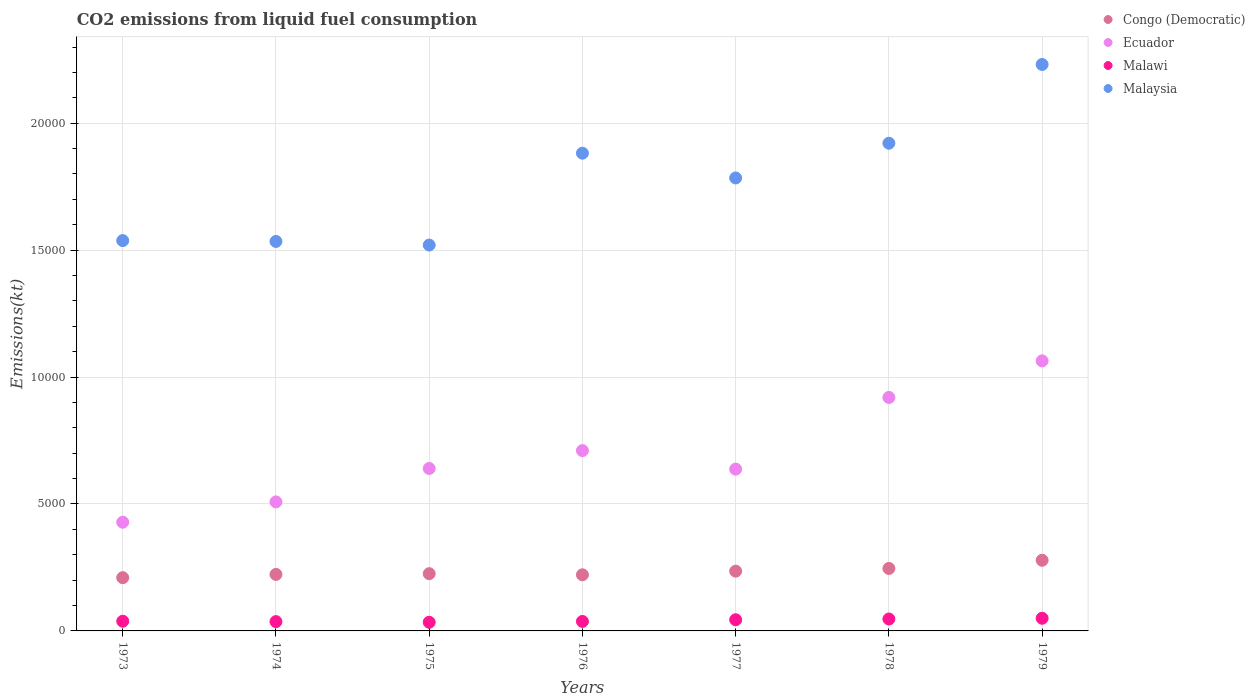How many different coloured dotlines are there?
Your answer should be compact. 4. Is the number of dotlines equal to the number of legend labels?
Make the answer very short. Yes. What is the amount of CO2 emitted in Ecuador in 1974?
Keep it short and to the point. 5082.46. Across all years, what is the maximum amount of CO2 emitted in Malawi?
Your answer should be compact. 498.71. Across all years, what is the minimum amount of CO2 emitted in Malawi?
Your response must be concise. 341.03. In which year was the amount of CO2 emitted in Malaysia maximum?
Offer a very short reply. 1979. What is the total amount of CO2 emitted in Malaysia in the graph?
Give a very brief answer. 1.24e+05. What is the difference between the amount of CO2 emitted in Congo (Democratic) in 1974 and that in 1975?
Offer a terse response. -29.34. What is the difference between the amount of CO2 emitted in Malawi in 1979 and the amount of CO2 emitted in Malaysia in 1978?
Provide a short and direct response. -1.87e+04. What is the average amount of CO2 emitted in Malaysia per year?
Your answer should be compact. 1.77e+04. In the year 1977, what is the difference between the amount of CO2 emitted in Malaysia and amount of CO2 emitted in Ecuador?
Offer a very short reply. 1.15e+04. In how many years, is the amount of CO2 emitted in Congo (Democratic) greater than 13000 kt?
Make the answer very short. 0. What is the ratio of the amount of CO2 emitted in Malaysia in 1977 to that in 1978?
Provide a succinct answer. 0.93. Is the amount of CO2 emitted in Congo (Democratic) in 1976 less than that in 1978?
Your answer should be very brief. Yes. What is the difference between the highest and the second highest amount of CO2 emitted in Malaysia?
Your response must be concise. 3102.28. What is the difference between the highest and the lowest amount of CO2 emitted in Congo (Democratic)?
Provide a succinct answer. 685.73. Is the sum of the amount of CO2 emitted in Malaysia in 1975 and 1977 greater than the maximum amount of CO2 emitted in Ecuador across all years?
Your response must be concise. Yes. Is it the case that in every year, the sum of the amount of CO2 emitted in Congo (Democratic) and amount of CO2 emitted in Ecuador  is greater than the amount of CO2 emitted in Malaysia?
Ensure brevity in your answer.  No. Does the amount of CO2 emitted in Ecuador monotonically increase over the years?
Provide a succinct answer. No. How many dotlines are there?
Offer a very short reply. 4. What is the difference between two consecutive major ticks on the Y-axis?
Offer a terse response. 5000. Does the graph contain any zero values?
Provide a short and direct response. No. Does the graph contain grids?
Provide a short and direct response. Yes. How many legend labels are there?
Provide a short and direct response. 4. What is the title of the graph?
Offer a terse response. CO2 emissions from liquid fuel consumption. Does "Lebanon" appear as one of the legend labels in the graph?
Offer a terse response. No. What is the label or title of the Y-axis?
Your answer should be compact. Emissions(kt). What is the Emissions(kt) of Congo (Democratic) in 1973?
Keep it short and to the point. 2097.52. What is the Emissions(kt) in Ecuador in 1973?
Your answer should be very brief. 4283.06. What is the Emissions(kt) in Malawi in 1973?
Keep it short and to the point. 381.37. What is the Emissions(kt) of Malaysia in 1973?
Your answer should be very brief. 1.54e+04. What is the Emissions(kt) in Congo (Democratic) in 1974?
Make the answer very short. 2225.87. What is the Emissions(kt) of Ecuador in 1974?
Give a very brief answer. 5082.46. What is the Emissions(kt) in Malawi in 1974?
Your response must be concise. 366.7. What is the Emissions(kt) in Malaysia in 1974?
Offer a very short reply. 1.53e+04. What is the Emissions(kt) in Congo (Democratic) in 1975?
Offer a terse response. 2255.2. What is the Emissions(kt) of Ecuador in 1975?
Provide a short and direct response. 6398.91. What is the Emissions(kt) in Malawi in 1975?
Offer a terse response. 341.03. What is the Emissions(kt) in Malaysia in 1975?
Keep it short and to the point. 1.52e+04. What is the Emissions(kt) of Congo (Democratic) in 1976?
Provide a short and direct response. 2211.2. What is the Emissions(kt) in Ecuador in 1976?
Offer a terse response. 7102.98. What is the Emissions(kt) in Malawi in 1976?
Make the answer very short. 374.03. What is the Emissions(kt) in Malaysia in 1976?
Keep it short and to the point. 1.88e+04. What is the Emissions(kt) of Congo (Democratic) in 1977?
Provide a succinct answer. 2354.21. What is the Emissions(kt) in Ecuador in 1977?
Offer a terse response. 6373.25. What is the Emissions(kt) in Malawi in 1977?
Your answer should be compact. 440.04. What is the Emissions(kt) in Malaysia in 1977?
Ensure brevity in your answer.  1.78e+04. What is the Emissions(kt) of Congo (Democratic) in 1978?
Ensure brevity in your answer.  2460.56. What is the Emissions(kt) of Ecuador in 1978?
Provide a succinct answer. 9196.84. What is the Emissions(kt) of Malawi in 1978?
Provide a short and direct response. 469.38. What is the Emissions(kt) of Malaysia in 1978?
Ensure brevity in your answer.  1.92e+04. What is the Emissions(kt) in Congo (Democratic) in 1979?
Provide a short and direct response. 2783.25. What is the Emissions(kt) of Ecuador in 1979?
Make the answer very short. 1.06e+04. What is the Emissions(kt) in Malawi in 1979?
Your answer should be very brief. 498.71. What is the Emissions(kt) in Malaysia in 1979?
Provide a short and direct response. 2.23e+04. Across all years, what is the maximum Emissions(kt) of Congo (Democratic)?
Provide a short and direct response. 2783.25. Across all years, what is the maximum Emissions(kt) in Ecuador?
Your answer should be compact. 1.06e+04. Across all years, what is the maximum Emissions(kt) of Malawi?
Ensure brevity in your answer.  498.71. Across all years, what is the maximum Emissions(kt) in Malaysia?
Provide a succinct answer. 2.23e+04. Across all years, what is the minimum Emissions(kt) in Congo (Democratic)?
Provide a short and direct response. 2097.52. Across all years, what is the minimum Emissions(kt) in Ecuador?
Keep it short and to the point. 4283.06. Across all years, what is the minimum Emissions(kt) of Malawi?
Your answer should be very brief. 341.03. Across all years, what is the minimum Emissions(kt) in Malaysia?
Offer a terse response. 1.52e+04. What is the total Emissions(kt) of Congo (Democratic) in the graph?
Give a very brief answer. 1.64e+04. What is the total Emissions(kt) in Ecuador in the graph?
Your answer should be very brief. 4.91e+04. What is the total Emissions(kt) in Malawi in the graph?
Your answer should be compact. 2871.26. What is the total Emissions(kt) in Malaysia in the graph?
Your answer should be very brief. 1.24e+05. What is the difference between the Emissions(kt) of Congo (Democratic) in 1973 and that in 1974?
Keep it short and to the point. -128.34. What is the difference between the Emissions(kt) of Ecuador in 1973 and that in 1974?
Provide a short and direct response. -799.41. What is the difference between the Emissions(kt) in Malawi in 1973 and that in 1974?
Ensure brevity in your answer.  14.67. What is the difference between the Emissions(kt) in Malaysia in 1973 and that in 1974?
Your response must be concise. 33. What is the difference between the Emissions(kt) of Congo (Democratic) in 1973 and that in 1975?
Make the answer very short. -157.68. What is the difference between the Emissions(kt) of Ecuador in 1973 and that in 1975?
Provide a succinct answer. -2115.86. What is the difference between the Emissions(kt) in Malawi in 1973 and that in 1975?
Ensure brevity in your answer.  40.34. What is the difference between the Emissions(kt) of Malaysia in 1973 and that in 1975?
Provide a short and direct response. 176.02. What is the difference between the Emissions(kt) of Congo (Democratic) in 1973 and that in 1976?
Provide a succinct answer. -113.68. What is the difference between the Emissions(kt) in Ecuador in 1973 and that in 1976?
Your answer should be very brief. -2819.92. What is the difference between the Emissions(kt) in Malawi in 1973 and that in 1976?
Offer a terse response. 7.33. What is the difference between the Emissions(kt) in Malaysia in 1973 and that in 1976?
Your answer should be very brief. -3443.31. What is the difference between the Emissions(kt) of Congo (Democratic) in 1973 and that in 1977?
Your response must be concise. -256.69. What is the difference between the Emissions(kt) in Ecuador in 1973 and that in 1977?
Give a very brief answer. -2090.19. What is the difference between the Emissions(kt) in Malawi in 1973 and that in 1977?
Ensure brevity in your answer.  -58.67. What is the difference between the Emissions(kt) in Malaysia in 1973 and that in 1977?
Ensure brevity in your answer.  -2467.89. What is the difference between the Emissions(kt) in Congo (Democratic) in 1973 and that in 1978?
Your answer should be compact. -363.03. What is the difference between the Emissions(kt) of Ecuador in 1973 and that in 1978?
Provide a short and direct response. -4913.78. What is the difference between the Emissions(kt) in Malawi in 1973 and that in 1978?
Give a very brief answer. -88.01. What is the difference between the Emissions(kt) of Malaysia in 1973 and that in 1978?
Your answer should be very brief. -3835.68. What is the difference between the Emissions(kt) in Congo (Democratic) in 1973 and that in 1979?
Provide a succinct answer. -685.73. What is the difference between the Emissions(kt) in Ecuador in 1973 and that in 1979?
Offer a very short reply. -6354.91. What is the difference between the Emissions(kt) of Malawi in 1973 and that in 1979?
Make the answer very short. -117.34. What is the difference between the Emissions(kt) in Malaysia in 1973 and that in 1979?
Provide a succinct answer. -6937.96. What is the difference between the Emissions(kt) of Congo (Democratic) in 1974 and that in 1975?
Provide a succinct answer. -29.34. What is the difference between the Emissions(kt) in Ecuador in 1974 and that in 1975?
Give a very brief answer. -1316.45. What is the difference between the Emissions(kt) of Malawi in 1974 and that in 1975?
Keep it short and to the point. 25.67. What is the difference between the Emissions(kt) in Malaysia in 1974 and that in 1975?
Make the answer very short. 143.01. What is the difference between the Emissions(kt) of Congo (Democratic) in 1974 and that in 1976?
Give a very brief answer. 14.67. What is the difference between the Emissions(kt) of Ecuador in 1974 and that in 1976?
Make the answer very short. -2020.52. What is the difference between the Emissions(kt) of Malawi in 1974 and that in 1976?
Offer a very short reply. -7.33. What is the difference between the Emissions(kt) of Malaysia in 1974 and that in 1976?
Your answer should be compact. -3476.32. What is the difference between the Emissions(kt) of Congo (Democratic) in 1974 and that in 1977?
Ensure brevity in your answer.  -128.34. What is the difference between the Emissions(kt) of Ecuador in 1974 and that in 1977?
Offer a terse response. -1290.78. What is the difference between the Emissions(kt) of Malawi in 1974 and that in 1977?
Provide a short and direct response. -73.34. What is the difference between the Emissions(kt) of Malaysia in 1974 and that in 1977?
Offer a terse response. -2500.89. What is the difference between the Emissions(kt) of Congo (Democratic) in 1974 and that in 1978?
Provide a succinct answer. -234.69. What is the difference between the Emissions(kt) of Ecuador in 1974 and that in 1978?
Your response must be concise. -4114.37. What is the difference between the Emissions(kt) in Malawi in 1974 and that in 1978?
Provide a short and direct response. -102.68. What is the difference between the Emissions(kt) of Malaysia in 1974 and that in 1978?
Provide a succinct answer. -3868.68. What is the difference between the Emissions(kt) in Congo (Democratic) in 1974 and that in 1979?
Give a very brief answer. -557.38. What is the difference between the Emissions(kt) of Ecuador in 1974 and that in 1979?
Make the answer very short. -5555.51. What is the difference between the Emissions(kt) in Malawi in 1974 and that in 1979?
Offer a very short reply. -132.01. What is the difference between the Emissions(kt) of Malaysia in 1974 and that in 1979?
Keep it short and to the point. -6970.97. What is the difference between the Emissions(kt) in Congo (Democratic) in 1975 and that in 1976?
Your answer should be compact. 44. What is the difference between the Emissions(kt) in Ecuador in 1975 and that in 1976?
Give a very brief answer. -704.06. What is the difference between the Emissions(kt) of Malawi in 1975 and that in 1976?
Make the answer very short. -33. What is the difference between the Emissions(kt) in Malaysia in 1975 and that in 1976?
Keep it short and to the point. -3619.33. What is the difference between the Emissions(kt) in Congo (Democratic) in 1975 and that in 1977?
Ensure brevity in your answer.  -99.01. What is the difference between the Emissions(kt) of Ecuador in 1975 and that in 1977?
Your response must be concise. 25.67. What is the difference between the Emissions(kt) of Malawi in 1975 and that in 1977?
Provide a short and direct response. -99.01. What is the difference between the Emissions(kt) in Malaysia in 1975 and that in 1977?
Your answer should be very brief. -2643.91. What is the difference between the Emissions(kt) in Congo (Democratic) in 1975 and that in 1978?
Provide a succinct answer. -205.35. What is the difference between the Emissions(kt) of Ecuador in 1975 and that in 1978?
Give a very brief answer. -2797.92. What is the difference between the Emissions(kt) in Malawi in 1975 and that in 1978?
Make the answer very short. -128.34. What is the difference between the Emissions(kt) in Malaysia in 1975 and that in 1978?
Offer a very short reply. -4011.7. What is the difference between the Emissions(kt) in Congo (Democratic) in 1975 and that in 1979?
Your answer should be very brief. -528.05. What is the difference between the Emissions(kt) in Ecuador in 1975 and that in 1979?
Give a very brief answer. -4239.05. What is the difference between the Emissions(kt) in Malawi in 1975 and that in 1979?
Your response must be concise. -157.68. What is the difference between the Emissions(kt) of Malaysia in 1975 and that in 1979?
Ensure brevity in your answer.  -7113.98. What is the difference between the Emissions(kt) in Congo (Democratic) in 1976 and that in 1977?
Offer a terse response. -143.01. What is the difference between the Emissions(kt) of Ecuador in 1976 and that in 1977?
Your response must be concise. 729.73. What is the difference between the Emissions(kt) in Malawi in 1976 and that in 1977?
Keep it short and to the point. -66.01. What is the difference between the Emissions(kt) of Malaysia in 1976 and that in 1977?
Your answer should be compact. 975.42. What is the difference between the Emissions(kt) of Congo (Democratic) in 1976 and that in 1978?
Your response must be concise. -249.36. What is the difference between the Emissions(kt) of Ecuador in 1976 and that in 1978?
Provide a succinct answer. -2093.86. What is the difference between the Emissions(kt) of Malawi in 1976 and that in 1978?
Provide a short and direct response. -95.34. What is the difference between the Emissions(kt) of Malaysia in 1976 and that in 1978?
Your answer should be very brief. -392.37. What is the difference between the Emissions(kt) of Congo (Democratic) in 1976 and that in 1979?
Make the answer very short. -572.05. What is the difference between the Emissions(kt) of Ecuador in 1976 and that in 1979?
Offer a very short reply. -3534.99. What is the difference between the Emissions(kt) of Malawi in 1976 and that in 1979?
Provide a succinct answer. -124.68. What is the difference between the Emissions(kt) in Malaysia in 1976 and that in 1979?
Ensure brevity in your answer.  -3494.65. What is the difference between the Emissions(kt) of Congo (Democratic) in 1977 and that in 1978?
Offer a terse response. -106.34. What is the difference between the Emissions(kt) in Ecuador in 1977 and that in 1978?
Ensure brevity in your answer.  -2823.59. What is the difference between the Emissions(kt) of Malawi in 1977 and that in 1978?
Offer a terse response. -29.34. What is the difference between the Emissions(kt) in Malaysia in 1977 and that in 1978?
Offer a very short reply. -1367.79. What is the difference between the Emissions(kt) of Congo (Democratic) in 1977 and that in 1979?
Offer a very short reply. -429.04. What is the difference between the Emissions(kt) of Ecuador in 1977 and that in 1979?
Ensure brevity in your answer.  -4264.72. What is the difference between the Emissions(kt) in Malawi in 1977 and that in 1979?
Your answer should be compact. -58.67. What is the difference between the Emissions(kt) in Malaysia in 1977 and that in 1979?
Ensure brevity in your answer.  -4470.07. What is the difference between the Emissions(kt) of Congo (Democratic) in 1978 and that in 1979?
Give a very brief answer. -322.7. What is the difference between the Emissions(kt) in Ecuador in 1978 and that in 1979?
Make the answer very short. -1441.13. What is the difference between the Emissions(kt) in Malawi in 1978 and that in 1979?
Make the answer very short. -29.34. What is the difference between the Emissions(kt) of Malaysia in 1978 and that in 1979?
Your response must be concise. -3102.28. What is the difference between the Emissions(kt) of Congo (Democratic) in 1973 and the Emissions(kt) of Ecuador in 1974?
Provide a short and direct response. -2984.94. What is the difference between the Emissions(kt) in Congo (Democratic) in 1973 and the Emissions(kt) in Malawi in 1974?
Offer a very short reply. 1730.82. What is the difference between the Emissions(kt) of Congo (Democratic) in 1973 and the Emissions(kt) of Malaysia in 1974?
Give a very brief answer. -1.32e+04. What is the difference between the Emissions(kt) in Ecuador in 1973 and the Emissions(kt) in Malawi in 1974?
Provide a succinct answer. 3916.36. What is the difference between the Emissions(kt) in Ecuador in 1973 and the Emissions(kt) in Malaysia in 1974?
Ensure brevity in your answer.  -1.11e+04. What is the difference between the Emissions(kt) of Malawi in 1973 and the Emissions(kt) of Malaysia in 1974?
Keep it short and to the point. -1.50e+04. What is the difference between the Emissions(kt) of Congo (Democratic) in 1973 and the Emissions(kt) of Ecuador in 1975?
Ensure brevity in your answer.  -4301.39. What is the difference between the Emissions(kt) of Congo (Democratic) in 1973 and the Emissions(kt) of Malawi in 1975?
Give a very brief answer. 1756.49. What is the difference between the Emissions(kt) in Congo (Democratic) in 1973 and the Emissions(kt) in Malaysia in 1975?
Your answer should be compact. -1.31e+04. What is the difference between the Emissions(kt) in Ecuador in 1973 and the Emissions(kt) in Malawi in 1975?
Offer a terse response. 3942.03. What is the difference between the Emissions(kt) in Ecuador in 1973 and the Emissions(kt) in Malaysia in 1975?
Make the answer very short. -1.09e+04. What is the difference between the Emissions(kt) of Malawi in 1973 and the Emissions(kt) of Malaysia in 1975?
Keep it short and to the point. -1.48e+04. What is the difference between the Emissions(kt) in Congo (Democratic) in 1973 and the Emissions(kt) in Ecuador in 1976?
Provide a succinct answer. -5005.45. What is the difference between the Emissions(kt) in Congo (Democratic) in 1973 and the Emissions(kt) in Malawi in 1976?
Ensure brevity in your answer.  1723.49. What is the difference between the Emissions(kt) of Congo (Democratic) in 1973 and the Emissions(kt) of Malaysia in 1976?
Keep it short and to the point. -1.67e+04. What is the difference between the Emissions(kt) of Ecuador in 1973 and the Emissions(kt) of Malawi in 1976?
Your answer should be very brief. 3909.02. What is the difference between the Emissions(kt) of Ecuador in 1973 and the Emissions(kt) of Malaysia in 1976?
Ensure brevity in your answer.  -1.45e+04. What is the difference between the Emissions(kt) of Malawi in 1973 and the Emissions(kt) of Malaysia in 1976?
Your response must be concise. -1.84e+04. What is the difference between the Emissions(kt) of Congo (Democratic) in 1973 and the Emissions(kt) of Ecuador in 1977?
Provide a short and direct response. -4275.72. What is the difference between the Emissions(kt) in Congo (Democratic) in 1973 and the Emissions(kt) in Malawi in 1977?
Your response must be concise. 1657.48. What is the difference between the Emissions(kt) in Congo (Democratic) in 1973 and the Emissions(kt) in Malaysia in 1977?
Provide a short and direct response. -1.57e+04. What is the difference between the Emissions(kt) in Ecuador in 1973 and the Emissions(kt) in Malawi in 1977?
Your answer should be very brief. 3843.02. What is the difference between the Emissions(kt) of Ecuador in 1973 and the Emissions(kt) of Malaysia in 1977?
Provide a succinct answer. -1.36e+04. What is the difference between the Emissions(kt) in Malawi in 1973 and the Emissions(kt) in Malaysia in 1977?
Your answer should be very brief. -1.75e+04. What is the difference between the Emissions(kt) of Congo (Democratic) in 1973 and the Emissions(kt) of Ecuador in 1978?
Offer a terse response. -7099.31. What is the difference between the Emissions(kt) in Congo (Democratic) in 1973 and the Emissions(kt) in Malawi in 1978?
Provide a short and direct response. 1628.15. What is the difference between the Emissions(kt) in Congo (Democratic) in 1973 and the Emissions(kt) in Malaysia in 1978?
Your response must be concise. -1.71e+04. What is the difference between the Emissions(kt) in Ecuador in 1973 and the Emissions(kt) in Malawi in 1978?
Provide a short and direct response. 3813.68. What is the difference between the Emissions(kt) of Ecuador in 1973 and the Emissions(kt) of Malaysia in 1978?
Offer a very short reply. -1.49e+04. What is the difference between the Emissions(kt) of Malawi in 1973 and the Emissions(kt) of Malaysia in 1978?
Keep it short and to the point. -1.88e+04. What is the difference between the Emissions(kt) of Congo (Democratic) in 1973 and the Emissions(kt) of Ecuador in 1979?
Keep it short and to the point. -8540.44. What is the difference between the Emissions(kt) of Congo (Democratic) in 1973 and the Emissions(kt) of Malawi in 1979?
Your response must be concise. 1598.81. What is the difference between the Emissions(kt) of Congo (Democratic) in 1973 and the Emissions(kt) of Malaysia in 1979?
Provide a succinct answer. -2.02e+04. What is the difference between the Emissions(kt) of Ecuador in 1973 and the Emissions(kt) of Malawi in 1979?
Your answer should be very brief. 3784.34. What is the difference between the Emissions(kt) in Ecuador in 1973 and the Emissions(kt) in Malaysia in 1979?
Your answer should be compact. -1.80e+04. What is the difference between the Emissions(kt) of Malawi in 1973 and the Emissions(kt) of Malaysia in 1979?
Offer a terse response. -2.19e+04. What is the difference between the Emissions(kt) of Congo (Democratic) in 1974 and the Emissions(kt) of Ecuador in 1975?
Provide a short and direct response. -4173.05. What is the difference between the Emissions(kt) of Congo (Democratic) in 1974 and the Emissions(kt) of Malawi in 1975?
Offer a very short reply. 1884.84. What is the difference between the Emissions(kt) of Congo (Democratic) in 1974 and the Emissions(kt) of Malaysia in 1975?
Offer a terse response. -1.30e+04. What is the difference between the Emissions(kt) in Ecuador in 1974 and the Emissions(kt) in Malawi in 1975?
Keep it short and to the point. 4741.43. What is the difference between the Emissions(kt) in Ecuador in 1974 and the Emissions(kt) in Malaysia in 1975?
Offer a very short reply. -1.01e+04. What is the difference between the Emissions(kt) of Malawi in 1974 and the Emissions(kt) of Malaysia in 1975?
Give a very brief answer. -1.48e+04. What is the difference between the Emissions(kt) in Congo (Democratic) in 1974 and the Emissions(kt) in Ecuador in 1976?
Ensure brevity in your answer.  -4877.11. What is the difference between the Emissions(kt) in Congo (Democratic) in 1974 and the Emissions(kt) in Malawi in 1976?
Give a very brief answer. 1851.84. What is the difference between the Emissions(kt) of Congo (Democratic) in 1974 and the Emissions(kt) of Malaysia in 1976?
Provide a short and direct response. -1.66e+04. What is the difference between the Emissions(kt) in Ecuador in 1974 and the Emissions(kt) in Malawi in 1976?
Your answer should be very brief. 4708.43. What is the difference between the Emissions(kt) in Ecuador in 1974 and the Emissions(kt) in Malaysia in 1976?
Offer a terse response. -1.37e+04. What is the difference between the Emissions(kt) in Malawi in 1974 and the Emissions(kt) in Malaysia in 1976?
Provide a short and direct response. -1.85e+04. What is the difference between the Emissions(kt) of Congo (Democratic) in 1974 and the Emissions(kt) of Ecuador in 1977?
Ensure brevity in your answer.  -4147.38. What is the difference between the Emissions(kt) in Congo (Democratic) in 1974 and the Emissions(kt) in Malawi in 1977?
Your answer should be compact. 1785.83. What is the difference between the Emissions(kt) of Congo (Democratic) in 1974 and the Emissions(kt) of Malaysia in 1977?
Give a very brief answer. -1.56e+04. What is the difference between the Emissions(kt) in Ecuador in 1974 and the Emissions(kt) in Malawi in 1977?
Your answer should be very brief. 4642.42. What is the difference between the Emissions(kt) in Ecuador in 1974 and the Emissions(kt) in Malaysia in 1977?
Provide a succinct answer. -1.28e+04. What is the difference between the Emissions(kt) of Malawi in 1974 and the Emissions(kt) of Malaysia in 1977?
Give a very brief answer. -1.75e+04. What is the difference between the Emissions(kt) of Congo (Democratic) in 1974 and the Emissions(kt) of Ecuador in 1978?
Make the answer very short. -6970.97. What is the difference between the Emissions(kt) in Congo (Democratic) in 1974 and the Emissions(kt) in Malawi in 1978?
Offer a very short reply. 1756.49. What is the difference between the Emissions(kt) of Congo (Democratic) in 1974 and the Emissions(kt) of Malaysia in 1978?
Provide a short and direct response. -1.70e+04. What is the difference between the Emissions(kt) in Ecuador in 1974 and the Emissions(kt) in Malawi in 1978?
Make the answer very short. 4613.09. What is the difference between the Emissions(kt) in Ecuador in 1974 and the Emissions(kt) in Malaysia in 1978?
Your answer should be very brief. -1.41e+04. What is the difference between the Emissions(kt) of Malawi in 1974 and the Emissions(kt) of Malaysia in 1978?
Your response must be concise. -1.88e+04. What is the difference between the Emissions(kt) in Congo (Democratic) in 1974 and the Emissions(kt) in Ecuador in 1979?
Make the answer very short. -8412.1. What is the difference between the Emissions(kt) of Congo (Democratic) in 1974 and the Emissions(kt) of Malawi in 1979?
Your answer should be very brief. 1727.16. What is the difference between the Emissions(kt) in Congo (Democratic) in 1974 and the Emissions(kt) in Malaysia in 1979?
Give a very brief answer. -2.01e+04. What is the difference between the Emissions(kt) of Ecuador in 1974 and the Emissions(kt) of Malawi in 1979?
Ensure brevity in your answer.  4583.75. What is the difference between the Emissions(kt) of Ecuador in 1974 and the Emissions(kt) of Malaysia in 1979?
Provide a short and direct response. -1.72e+04. What is the difference between the Emissions(kt) in Malawi in 1974 and the Emissions(kt) in Malaysia in 1979?
Provide a short and direct response. -2.19e+04. What is the difference between the Emissions(kt) in Congo (Democratic) in 1975 and the Emissions(kt) in Ecuador in 1976?
Keep it short and to the point. -4847.77. What is the difference between the Emissions(kt) of Congo (Democratic) in 1975 and the Emissions(kt) of Malawi in 1976?
Your answer should be very brief. 1881.17. What is the difference between the Emissions(kt) in Congo (Democratic) in 1975 and the Emissions(kt) in Malaysia in 1976?
Ensure brevity in your answer.  -1.66e+04. What is the difference between the Emissions(kt) in Ecuador in 1975 and the Emissions(kt) in Malawi in 1976?
Offer a very short reply. 6024.88. What is the difference between the Emissions(kt) in Ecuador in 1975 and the Emissions(kt) in Malaysia in 1976?
Offer a very short reply. -1.24e+04. What is the difference between the Emissions(kt) of Malawi in 1975 and the Emissions(kt) of Malaysia in 1976?
Your answer should be compact. -1.85e+04. What is the difference between the Emissions(kt) of Congo (Democratic) in 1975 and the Emissions(kt) of Ecuador in 1977?
Provide a short and direct response. -4118.04. What is the difference between the Emissions(kt) in Congo (Democratic) in 1975 and the Emissions(kt) in Malawi in 1977?
Ensure brevity in your answer.  1815.16. What is the difference between the Emissions(kt) of Congo (Democratic) in 1975 and the Emissions(kt) of Malaysia in 1977?
Your response must be concise. -1.56e+04. What is the difference between the Emissions(kt) in Ecuador in 1975 and the Emissions(kt) in Malawi in 1977?
Offer a terse response. 5958.88. What is the difference between the Emissions(kt) of Ecuador in 1975 and the Emissions(kt) of Malaysia in 1977?
Provide a short and direct response. -1.14e+04. What is the difference between the Emissions(kt) in Malawi in 1975 and the Emissions(kt) in Malaysia in 1977?
Your answer should be very brief. -1.75e+04. What is the difference between the Emissions(kt) in Congo (Democratic) in 1975 and the Emissions(kt) in Ecuador in 1978?
Provide a succinct answer. -6941.63. What is the difference between the Emissions(kt) in Congo (Democratic) in 1975 and the Emissions(kt) in Malawi in 1978?
Your answer should be very brief. 1785.83. What is the difference between the Emissions(kt) of Congo (Democratic) in 1975 and the Emissions(kt) of Malaysia in 1978?
Offer a very short reply. -1.70e+04. What is the difference between the Emissions(kt) of Ecuador in 1975 and the Emissions(kt) of Malawi in 1978?
Your answer should be compact. 5929.54. What is the difference between the Emissions(kt) of Ecuador in 1975 and the Emissions(kt) of Malaysia in 1978?
Offer a very short reply. -1.28e+04. What is the difference between the Emissions(kt) of Malawi in 1975 and the Emissions(kt) of Malaysia in 1978?
Offer a very short reply. -1.89e+04. What is the difference between the Emissions(kt) of Congo (Democratic) in 1975 and the Emissions(kt) of Ecuador in 1979?
Offer a very short reply. -8382.76. What is the difference between the Emissions(kt) of Congo (Democratic) in 1975 and the Emissions(kt) of Malawi in 1979?
Offer a very short reply. 1756.49. What is the difference between the Emissions(kt) in Congo (Democratic) in 1975 and the Emissions(kt) in Malaysia in 1979?
Your answer should be compact. -2.01e+04. What is the difference between the Emissions(kt) in Ecuador in 1975 and the Emissions(kt) in Malawi in 1979?
Make the answer very short. 5900.2. What is the difference between the Emissions(kt) of Ecuador in 1975 and the Emissions(kt) of Malaysia in 1979?
Your answer should be compact. -1.59e+04. What is the difference between the Emissions(kt) of Malawi in 1975 and the Emissions(kt) of Malaysia in 1979?
Ensure brevity in your answer.  -2.20e+04. What is the difference between the Emissions(kt) in Congo (Democratic) in 1976 and the Emissions(kt) in Ecuador in 1977?
Keep it short and to the point. -4162.05. What is the difference between the Emissions(kt) in Congo (Democratic) in 1976 and the Emissions(kt) in Malawi in 1977?
Your answer should be compact. 1771.16. What is the difference between the Emissions(kt) of Congo (Democratic) in 1976 and the Emissions(kt) of Malaysia in 1977?
Offer a very short reply. -1.56e+04. What is the difference between the Emissions(kt) of Ecuador in 1976 and the Emissions(kt) of Malawi in 1977?
Offer a terse response. 6662.94. What is the difference between the Emissions(kt) in Ecuador in 1976 and the Emissions(kt) in Malaysia in 1977?
Your answer should be very brief. -1.07e+04. What is the difference between the Emissions(kt) of Malawi in 1976 and the Emissions(kt) of Malaysia in 1977?
Give a very brief answer. -1.75e+04. What is the difference between the Emissions(kt) of Congo (Democratic) in 1976 and the Emissions(kt) of Ecuador in 1978?
Your answer should be very brief. -6985.64. What is the difference between the Emissions(kt) of Congo (Democratic) in 1976 and the Emissions(kt) of Malawi in 1978?
Your answer should be very brief. 1741.83. What is the difference between the Emissions(kt) in Congo (Democratic) in 1976 and the Emissions(kt) in Malaysia in 1978?
Keep it short and to the point. -1.70e+04. What is the difference between the Emissions(kt) of Ecuador in 1976 and the Emissions(kt) of Malawi in 1978?
Make the answer very short. 6633.6. What is the difference between the Emissions(kt) in Ecuador in 1976 and the Emissions(kt) in Malaysia in 1978?
Provide a succinct answer. -1.21e+04. What is the difference between the Emissions(kt) in Malawi in 1976 and the Emissions(kt) in Malaysia in 1978?
Keep it short and to the point. -1.88e+04. What is the difference between the Emissions(kt) of Congo (Democratic) in 1976 and the Emissions(kt) of Ecuador in 1979?
Provide a short and direct response. -8426.77. What is the difference between the Emissions(kt) of Congo (Democratic) in 1976 and the Emissions(kt) of Malawi in 1979?
Keep it short and to the point. 1712.49. What is the difference between the Emissions(kt) in Congo (Democratic) in 1976 and the Emissions(kt) in Malaysia in 1979?
Provide a succinct answer. -2.01e+04. What is the difference between the Emissions(kt) in Ecuador in 1976 and the Emissions(kt) in Malawi in 1979?
Provide a succinct answer. 6604.27. What is the difference between the Emissions(kt) of Ecuador in 1976 and the Emissions(kt) of Malaysia in 1979?
Provide a short and direct response. -1.52e+04. What is the difference between the Emissions(kt) in Malawi in 1976 and the Emissions(kt) in Malaysia in 1979?
Give a very brief answer. -2.19e+04. What is the difference between the Emissions(kt) of Congo (Democratic) in 1977 and the Emissions(kt) of Ecuador in 1978?
Provide a short and direct response. -6842.62. What is the difference between the Emissions(kt) in Congo (Democratic) in 1977 and the Emissions(kt) in Malawi in 1978?
Ensure brevity in your answer.  1884.84. What is the difference between the Emissions(kt) of Congo (Democratic) in 1977 and the Emissions(kt) of Malaysia in 1978?
Provide a short and direct response. -1.69e+04. What is the difference between the Emissions(kt) of Ecuador in 1977 and the Emissions(kt) of Malawi in 1978?
Offer a terse response. 5903.87. What is the difference between the Emissions(kt) in Ecuador in 1977 and the Emissions(kt) in Malaysia in 1978?
Ensure brevity in your answer.  -1.28e+04. What is the difference between the Emissions(kt) of Malawi in 1977 and the Emissions(kt) of Malaysia in 1978?
Keep it short and to the point. -1.88e+04. What is the difference between the Emissions(kt) in Congo (Democratic) in 1977 and the Emissions(kt) in Ecuador in 1979?
Ensure brevity in your answer.  -8283.75. What is the difference between the Emissions(kt) of Congo (Democratic) in 1977 and the Emissions(kt) of Malawi in 1979?
Your response must be concise. 1855.5. What is the difference between the Emissions(kt) in Congo (Democratic) in 1977 and the Emissions(kt) in Malaysia in 1979?
Your answer should be very brief. -2.00e+04. What is the difference between the Emissions(kt) of Ecuador in 1977 and the Emissions(kt) of Malawi in 1979?
Your answer should be compact. 5874.53. What is the difference between the Emissions(kt) in Ecuador in 1977 and the Emissions(kt) in Malaysia in 1979?
Your response must be concise. -1.59e+04. What is the difference between the Emissions(kt) in Malawi in 1977 and the Emissions(kt) in Malaysia in 1979?
Your response must be concise. -2.19e+04. What is the difference between the Emissions(kt) in Congo (Democratic) in 1978 and the Emissions(kt) in Ecuador in 1979?
Offer a very short reply. -8177.41. What is the difference between the Emissions(kt) of Congo (Democratic) in 1978 and the Emissions(kt) of Malawi in 1979?
Your response must be concise. 1961.85. What is the difference between the Emissions(kt) in Congo (Democratic) in 1978 and the Emissions(kt) in Malaysia in 1979?
Provide a succinct answer. -1.99e+04. What is the difference between the Emissions(kt) in Ecuador in 1978 and the Emissions(kt) in Malawi in 1979?
Provide a short and direct response. 8698.12. What is the difference between the Emissions(kt) in Ecuador in 1978 and the Emissions(kt) in Malaysia in 1979?
Keep it short and to the point. -1.31e+04. What is the difference between the Emissions(kt) in Malawi in 1978 and the Emissions(kt) in Malaysia in 1979?
Offer a very short reply. -2.18e+04. What is the average Emissions(kt) in Congo (Democratic) per year?
Provide a short and direct response. 2341.12. What is the average Emissions(kt) in Ecuador per year?
Provide a short and direct response. 7010.78. What is the average Emissions(kt) in Malawi per year?
Your answer should be compact. 410.18. What is the average Emissions(kt) in Malaysia per year?
Your response must be concise. 1.77e+04. In the year 1973, what is the difference between the Emissions(kt) in Congo (Democratic) and Emissions(kt) in Ecuador?
Your answer should be compact. -2185.53. In the year 1973, what is the difference between the Emissions(kt) of Congo (Democratic) and Emissions(kt) of Malawi?
Keep it short and to the point. 1716.16. In the year 1973, what is the difference between the Emissions(kt) in Congo (Democratic) and Emissions(kt) in Malaysia?
Your answer should be very brief. -1.33e+04. In the year 1973, what is the difference between the Emissions(kt) of Ecuador and Emissions(kt) of Malawi?
Your answer should be very brief. 3901.69. In the year 1973, what is the difference between the Emissions(kt) in Ecuador and Emissions(kt) in Malaysia?
Provide a succinct answer. -1.11e+04. In the year 1973, what is the difference between the Emissions(kt) of Malawi and Emissions(kt) of Malaysia?
Keep it short and to the point. -1.50e+04. In the year 1974, what is the difference between the Emissions(kt) of Congo (Democratic) and Emissions(kt) of Ecuador?
Your answer should be compact. -2856.59. In the year 1974, what is the difference between the Emissions(kt) in Congo (Democratic) and Emissions(kt) in Malawi?
Your answer should be very brief. 1859.17. In the year 1974, what is the difference between the Emissions(kt) of Congo (Democratic) and Emissions(kt) of Malaysia?
Your response must be concise. -1.31e+04. In the year 1974, what is the difference between the Emissions(kt) of Ecuador and Emissions(kt) of Malawi?
Your answer should be compact. 4715.76. In the year 1974, what is the difference between the Emissions(kt) of Ecuador and Emissions(kt) of Malaysia?
Provide a succinct answer. -1.03e+04. In the year 1974, what is the difference between the Emissions(kt) in Malawi and Emissions(kt) in Malaysia?
Provide a succinct answer. -1.50e+04. In the year 1975, what is the difference between the Emissions(kt) of Congo (Democratic) and Emissions(kt) of Ecuador?
Keep it short and to the point. -4143.71. In the year 1975, what is the difference between the Emissions(kt) in Congo (Democratic) and Emissions(kt) in Malawi?
Make the answer very short. 1914.17. In the year 1975, what is the difference between the Emissions(kt) of Congo (Democratic) and Emissions(kt) of Malaysia?
Ensure brevity in your answer.  -1.29e+04. In the year 1975, what is the difference between the Emissions(kt) of Ecuador and Emissions(kt) of Malawi?
Make the answer very short. 6057.88. In the year 1975, what is the difference between the Emissions(kt) in Ecuador and Emissions(kt) in Malaysia?
Your response must be concise. -8800.8. In the year 1975, what is the difference between the Emissions(kt) of Malawi and Emissions(kt) of Malaysia?
Your answer should be very brief. -1.49e+04. In the year 1976, what is the difference between the Emissions(kt) in Congo (Democratic) and Emissions(kt) in Ecuador?
Give a very brief answer. -4891.78. In the year 1976, what is the difference between the Emissions(kt) of Congo (Democratic) and Emissions(kt) of Malawi?
Provide a short and direct response. 1837.17. In the year 1976, what is the difference between the Emissions(kt) of Congo (Democratic) and Emissions(kt) of Malaysia?
Give a very brief answer. -1.66e+04. In the year 1976, what is the difference between the Emissions(kt) in Ecuador and Emissions(kt) in Malawi?
Make the answer very short. 6728.94. In the year 1976, what is the difference between the Emissions(kt) in Ecuador and Emissions(kt) in Malaysia?
Ensure brevity in your answer.  -1.17e+04. In the year 1976, what is the difference between the Emissions(kt) of Malawi and Emissions(kt) of Malaysia?
Your response must be concise. -1.84e+04. In the year 1977, what is the difference between the Emissions(kt) in Congo (Democratic) and Emissions(kt) in Ecuador?
Give a very brief answer. -4019.03. In the year 1977, what is the difference between the Emissions(kt) in Congo (Democratic) and Emissions(kt) in Malawi?
Provide a short and direct response. 1914.17. In the year 1977, what is the difference between the Emissions(kt) in Congo (Democratic) and Emissions(kt) in Malaysia?
Offer a terse response. -1.55e+04. In the year 1977, what is the difference between the Emissions(kt) in Ecuador and Emissions(kt) in Malawi?
Your response must be concise. 5933.21. In the year 1977, what is the difference between the Emissions(kt) of Ecuador and Emissions(kt) of Malaysia?
Your answer should be very brief. -1.15e+04. In the year 1977, what is the difference between the Emissions(kt) in Malawi and Emissions(kt) in Malaysia?
Your response must be concise. -1.74e+04. In the year 1978, what is the difference between the Emissions(kt) of Congo (Democratic) and Emissions(kt) of Ecuador?
Give a very brief answer. -6736.28. In the year 1978, what is the difference between the Emissions(kt) in Congo (Democratic) and Emissions(kt) in Malawi?
Your response must be concise. 1991.18. In the year 1978, what is the difference between the Emissions(kt) of Congo (Democratic) and Emissions(kt) of Malaysia?
Provide a short and direct response. -1.68e+04. In the year 1978, what is the difference between the Emissions(kt) in Ecuador and Emissions(kt) in Malawi?
Offer a very short reply. 8727.46. In the year 1978, what is the difference between the Emissions(kt) in Ecuador and Emissions(kt) in Malaysia?
Offer a very short reply. -1.00e+04. In the year 1978, what is the difference between the Emissions(kt) in Malawi and Emissions(kt) in Malaysia?
Keep it short and to the point. -1.87e+04. In the year 1979, what is the difference between the Emissions(kt) of Congo (Democratic) and Emissions(kt) of Ecuador?
Make the answer very short. -7854.71. In the year 1979, what is the difference between the Emissions(kt) in Congo (Democratic) and Emissions(kt) in Malawi?
Give a very brief answer. 2284.54. In the year 1979, what is the difference between the Emissions(kt) of Congo (Democratic) and Emissions(kt) of Malaysia?
Your answer should be very brief. -1.95e+04. In the year 1979, what is the difference between the Emissions(kt) of Ecuador and Emissions(kt) of Malawi?
Ensure brevity in your answer.  1.01e+04. In the year 1979, what is the difference between the Emissions(kt) of Ecuador and Emissions(kt) of Malaysia?
Your response must be concise. -1.17e+04. In the year 1979, what is the difference between the Emissions(kt) in Malawi and Emissions(kt) in Malaysia?
Make the answer very short. -2.18e+04. What is the ratio of the Emissions(kt) of Congo (Democratic) in 1973 to that in 1974?
Give a very brief answer. 0.94. What is the ratio of the Emissions(kt) in Ecuador in 1973 to that in 1974?
Offer a terse response. 0.84. What is the ratio of the Emissions(kt) in Malaysia in 1973 to that in 1974?
Your answer should be compact. 1. What is the ratio of the Emissions(kt) of Congo (Democratic) in 1973 to that in 1975?
Offer a very short reply. 0.93. What is the ratio of the Emissions(kt) of Ecuador in 1973 to that in 1975?
Offer a terse response. 0.67. What is the ratio of the Emissions(kt) of Malawi in 1973 to that in 1975?
Your response must be concise. 1.12. What is the ratio of the Emissions(kt) of Malaysia in 1973 to that in 1975?
Provide a short and direct response. 1.01. What is the ratio of the Emissions(kt) of Congo (Democratic) in 1973 to that in 1976?
Provide a succinct answer. 0.95. What is the ratio of the Emissions(kt) in Ecuador in 1973 to that in 1976?
Ensure brevity in your answer.  0.6. What is the ratio of the Emissions(kt) in Malawi in 1973 to that in 1976?
Offer a terse response. 1.02. What is the ratio of the Emissions(kt) in Malaysia in 1973 to that in 1976?
Make the answer very short. 0.82. What is the ratio of the Emissions(kt) of Congo (Democratic) in 1973 to that in 1977?
Provide a short and direct response. 0.89. What is the ratio of the Emissions(kt) of Ecuador in 1973 to that in 1977?
Offer a terse response. 0.67. What is the ratio of the Emissions(kt) of Malawi in 1973 to that in 1977?
Provide a short and direct response. 0.87. What is the ratio of the Emissions(kt) of Malaysia in 1973 to that in 1977?
Your answer should be very brief. 0.86. What is the ratio of the Emissions(kt) in Congo (Democratic) in 1973 to that in 1978?
Keep it short and to the point. 0.85. What is the ratio of the Emissions(kt) of Ecuador in 1973 to that in 1978?
Provide a short and direct response. 0.47. What is the ratio of the Emissions(kt) in Malawi in 1973 to that in 1978?
Your response must be concise. 0.81. What is the ratio of the Emissions(kt) in Malaysia in 1973 to that in 1978?
Give a very brief answer. 0.8. What is the ratio of the Emissions(kt) of Congo (Democratic) in 1973 to that in 1979?
Keep it short and to the point. 0.75. What is the ratio of the Emissions(kt) of Ecuador in 1973 to that in 1979?
Provide a short and direct response. 0.4. What is the ratio of the Emissions(kt) of Malawi in 1973 to that in 1979?
Offer a terse response. 0.76. What is the ratio of the Emissions(kt) of Malaysia in 1973 to that in 1979?
Give a very brief answer. 0.69. What is the ratio of the Emissions(kt) in Congo (Democratic) in 1974 to that in 1975?
Offer a very short reply. 0.99. What is the ratio of the Emissions(kt) in Ecuador in 1974 to that in 1975?
Make the answer very short. 0.79. What is the ratio of the Emissions(kt) in Malawi in 1974 to that in 1975?
Provide a succinct answer. 1.08. What is the ratio of the Emissions(kt) in Malaysia in 1974 to that in 1975?
Offer a terse response. 1.01. What is the ratio of the Emissions(kt) in Congo (Democratic) in 1974 to that in 1976?
Your answer should be compact. 1.01. What is the ratio of the Emissions(kt) in Ecuador in 1974 to that in 1976?
Give a very brief answer. 0.72. What is the ratio of the Emissions(kt) in Malawi in 1974 to that in 1976?
Ensure brevity in your answer.  0.98. What is the ratio of the Emissions(kt) in Malaysia in 1974 to that in 1976?
Offer a very short reply. 0.82. What is the ratio of the Emissions(kt) of Congo (Democratic) in 1974 to that in 1977?
Give a very brief answer. 0.95. What is the ratio of the Emissions(kt) in Ecuador in 1974 to that in 1977?
Your response must be concise. 0.8. What is the ratio of the Emissions(kt) in Malawi in 1974 to that in 1977?
Your answer should be very brief. 0.83. What is the ratio of the Emissions(kt) in Malaysia in 1974 to that in 1977?
Give a very brief answer. 0.86. What is the ratio of the Emissions(kt) of Congo (Democratic) in 1974 to that in 1978?
Keep it short and to the point. 0.9. What is the ratio of the Emissions(kt) in Ecuador in 1974 to that in 1978?
Ensure brevity in your answer.  0.55. What is the ratio of the Emissions(kt) of Malawi in 1974 to that in 1978?
Provide a succinct answer. 0.78. What is the ratio of the Emissions(kt) of Malaysia in 1974 to that in 1978?
Keep it short and to the point. 0.8. What is the ratio of the Emissions(kt) in Congo (Democratic) in 1974 to that in 1979?
Give a very brief answer. 0.8. What is the ratio of the Emissions(kt) in Ecuador in 1974 to that in 1979?
Keep it short and to the point. 0.48. What is the ratio of the Emissions(kt) in Malawi in 1974 to that in 1979?
Offer a terse response. 0.74. What is the ratio of the Emissions(kt) of Malaysia in 1974 to that in 1979?
Provide a succinct answer. 0.69. What is the ratio of the Emissions(kt) of Congo (Democratic) in 1975 to that in 1976?
Your answer should be compact. 1.02. What is the ratio of the Emissions(kt) in Ecuador in 1975 to that in 1976?
Provide a short and direct response. 0.9. What is the ratio of the Emissions(kt) of Malawi in 1975 to that in 1976?
Give a very brief answer. 0.91. What is the ratio of the Emissions(kt) in Malaysia in 1975 to that in 1976?
Give a very brief answer. 0.81. What is the ratio of the Emissions(kt) of Congo (Democratic) in 1975 to that in 1977?
Keep it short and to the point. 0.96. What is the ratio of the Emissions(kt) in Malawi in 1975 to that in 1977?
Your response must be concise. 0.78. What is the ratio of the Emissions(kt) in Malaysia in 1975 to that in 1977?
Your response must be concise. 0.85. What is the ratio of the Emissions(kt) in Congo (Democratic) in 1975 to that in 1978?
Your answer should be very brief. 0.92. What is the ratio of the Emissions(kt) in Ecuador in 1975 to that in 1978?
Ensure brevity in your answer.  0.7. What is the ratio of the Emissions(kt) in Malawi in 1975 to that in 1978?
Ensure brevity in your answer.  0.73. What is the ratio of the Emissions(kt) of Malaysia in 1975 to that in 1978?
Ensure brevity in your answer.  0.79. What is the ratio of the Emissions(kt) in Congo (Democratic) in 1975 to that in 1979?
Keep it short and to the point. 0.81. What is the ratio of the Emissions(kt) in Ecuador in 1975 to that in 1979?
Keep it short and to the point. 0.6. What is the ratio of the Emissions(kt) of Malawi in 1975 to that in 1979?
Your response must be concise. 0.68. What is the ratio of the Emissions(kt) of Malaysia in 1975 to that in 1979?
Offer a very short reply. 0.68. What is the ratio of the Emissions(kt) of Congo (Democratic) in 1976 to that in 1977?
Provide a succinct answer. 0.94. What is the ratio of the Emissions(kt) in Ecuador in 1976 to that in 1977?
Offer a terse response. 1.11. What is the ratio of the Emissions(kt) in Malaysia in 1976 to that in 1977?
Provide a short and direct response. 1.05. What is the ratio of the Emissions(kt) of Congo (Democratic) in 1976 to that in 1978?
Provide a succinct answer. 0.9. What is the ratio of the Emissions(kt) of Ecuador in 1976 to that in 1978?
Your answer should be very brief. 0.77. What is the ratio of the Emissions(kt) in Malawi in 1976 to that in 1978?
Your response must be concise. 0.8. What is the ratio of the Emissions(kt) of Malaysia in 1976 to that in 1978?
Offer a terse response. 0.98. What is the ratio of the Emissions(kt) of Congo (Democratic) in 1976 to that in 1979?
Keep it short and to the point. 0.79. What is the ratio of the Emissions(kt) of Ecuador in 1976 to that in 1979?
Give a very brief answer. 0.67. What is the ratio of the Emissions(kt) of Malaysia in 1976 to that in 1979?
Your response must be concise. 0.84. What is the ratio of the Emissions(kt) of Congo (Democratic) in 1977 to that in 1978?
Keep it short and to the point. 0.96. What is the ratio of the Emissions(kt) of Ecuador in 1977 to that in 1978?
Provide a short and direct response. 0.69. What is the ratio of the Emissions(kt) of Malaysia in 1977 to that in 1978?
Give a very brief answer. 0.93. What is the ratio of the Emissions(kt) in Congo (Democratic) in 1977 to that in 1979?
Your answer should be compact. 0.85. What is the ratio of the Emissions(kt) of Ecuador in 1977 to that in 1979?
Offer a very short reply. 0.6. What is the ratio of the Emissions(kt) of Malawi in 1977 to that in 1979?
Ensure brevity in your answer.  0.88. What is the ratio of the Emissions(kt) in Malaysia in 1977 to that in 1979?
Your response must be concise. 0.8. What is the ratio of the Emissions(kt) of Congo (Democratic) in 1978 to that in 1979?
Provide a succinct answer. 0.88. What is the ratio of the Emissions(kt) of Ecuador in 1978 to that in 1979?
Make the answer very short. 0.86. What is the ratio of the Emissions(kt) in Malawi in 1978 to that in 1979?
Offer a very short reply. 0.94. What is the ratio of the Emissions(kt) in Malaysia in 1978 to that in 1979?
Your answer should be compact. 0.86. What is the difference between the highest and the second highest Emissions(kt) of Congo (Democratic)?
Keep it short and to the point. 322.7. What is the difference between the highest and the second highest Emissions(kt) in Ecuador?
Make the answer very short. 1441.13. What is the difference between the highest and the second highest Emissions(kt) of Malawi?
Give a very brief answer. 29.34. What is the difference between the highest and the second highest Emissions(kt) in Malaysia?
Your response must be concise. 3102.28. What is the difference between the highest and the lowest Emissions(kt) in Congo (Democratic)?
Your answer should be very brief. 685.73. What is the difference between the highest and the lowest Emissions(kt) of Ecuador?
Your answer should be very brief. 6354.91. What is the difference between the highest and the lowest Emissions(kt) in Malawi?
Offer a terse response. 157.68. What is the difference between the highest and the lowest Emissions(kt) in Malaysia?
Your answer should be compact. 7113.98. 